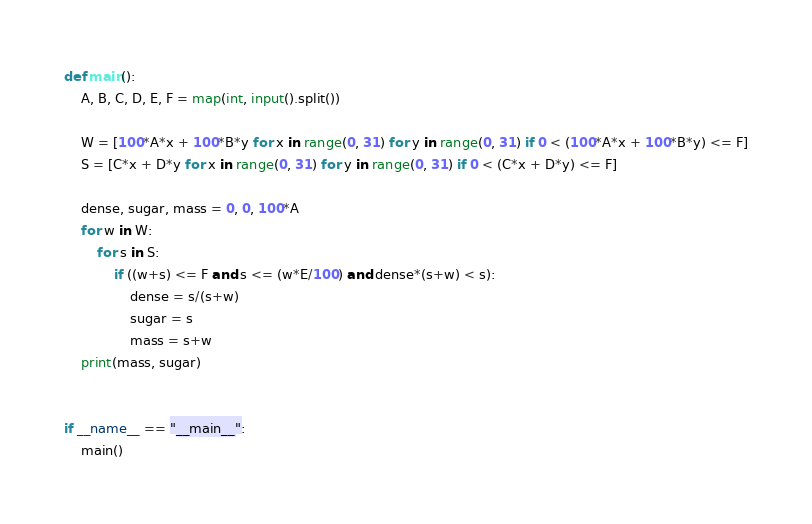<code> <loc_0><loc_0><loc_500><loc_500><_Python_>def main():
    A, B, C, D, E, F = map(int, input().split())

    W = [100*A*x + 100*B*y for x in range(0, 31) for y in range(0, 31) if 0 < (100*A*x + 100*B*y) <= F]
    S = [C*x + D*y for x in range(0, 31) for y in range(0, 31) if 0 < (C*x + D*y) <= F]

    dense, sugar, mass = 0, 0, 100*A
    for w in W:
        for s in S:
            if ((w+s) <= F and s <= (w*E/100) and dense*(s+w) < s):
                dense = s/(s+w)
                sugar = s
                mass = s+w
    print(mass, sugar)

    
if __name__ == "__main__":
    main()</code> 